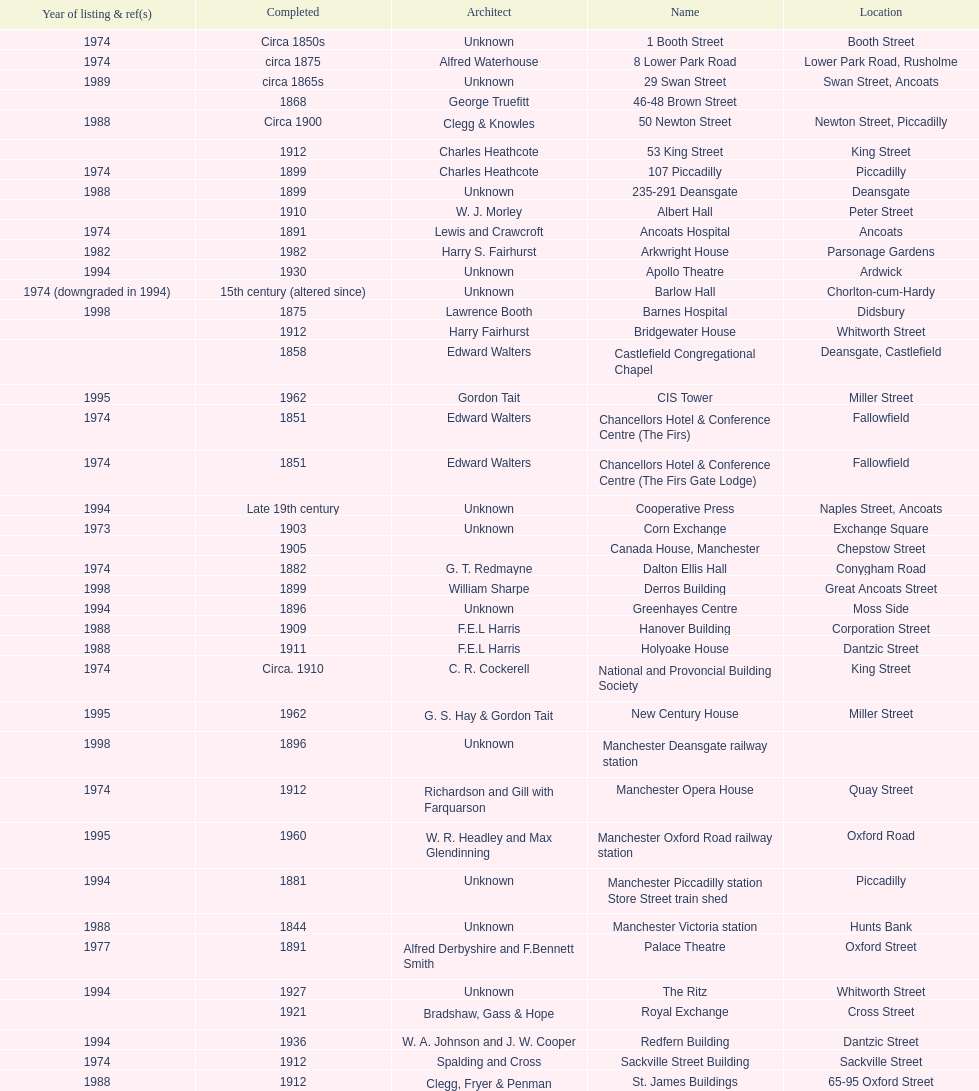How many buildings has the same year of listing as 1974? 15. 